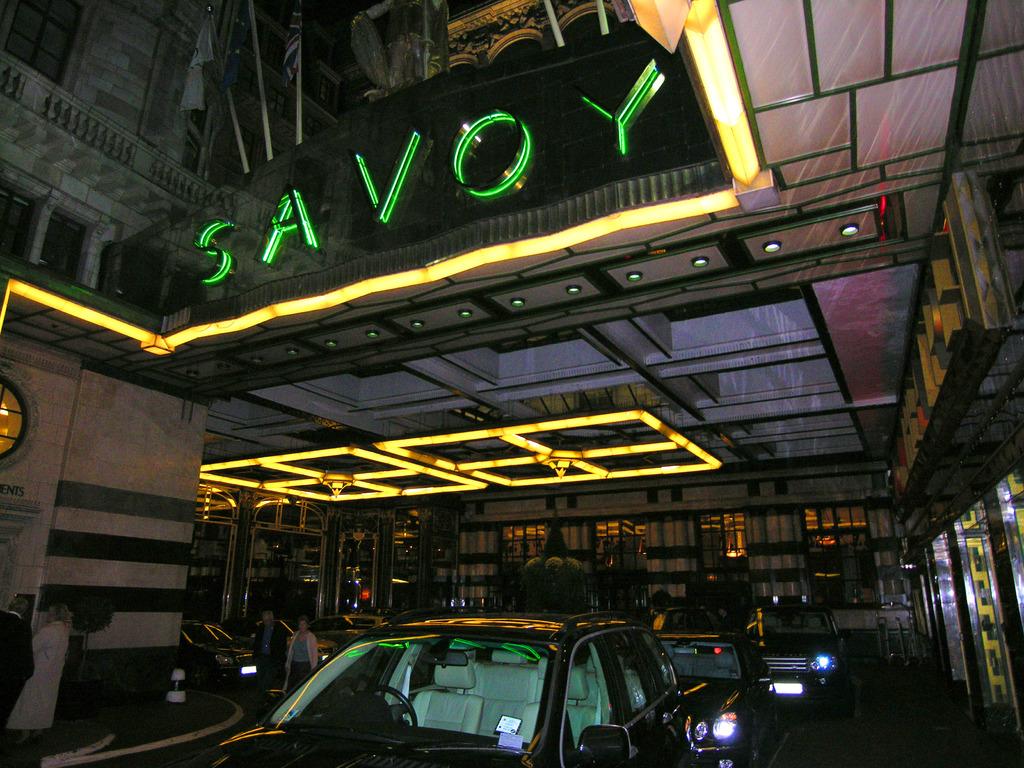The green letters read?
Provide a short and direct response. Savoy. 